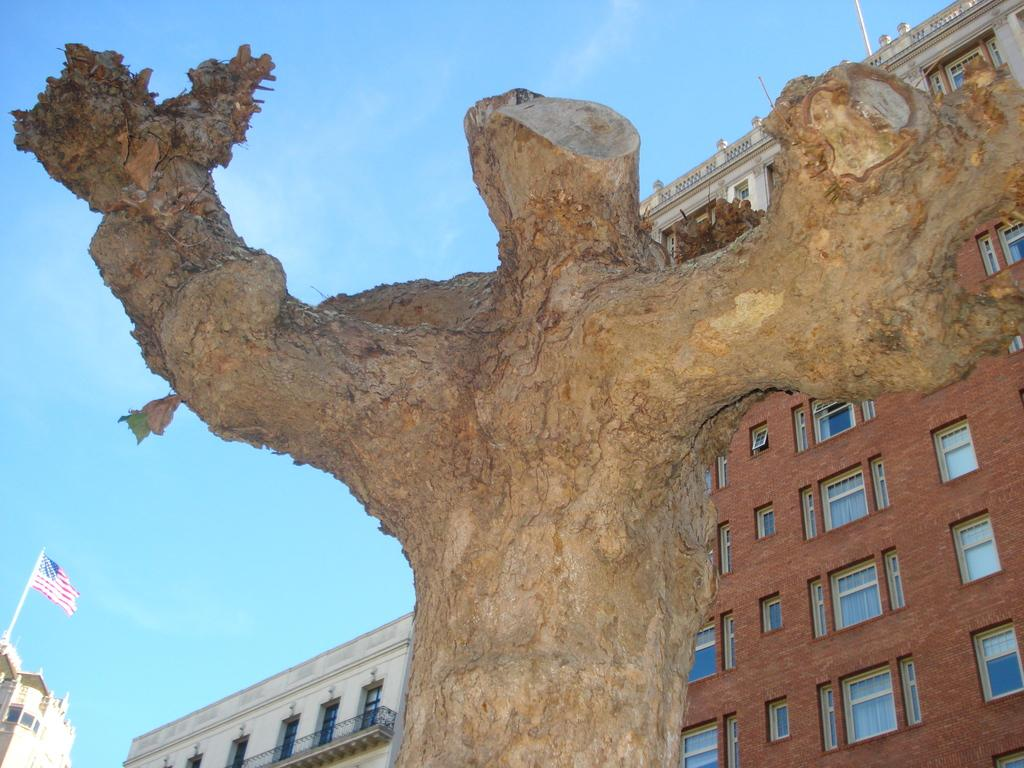What is the main subject in the center of the image? There is a tree trunk in the center of the image. What can be seen in the background of the image? There are two buildings in the background of the image. What other object is present in the image? There is a flag in the image. What is visible at the top of the image? The sky is visible at the top of the image. Can you describe the action of the robin in the image? There is no robin present in the image, so no action involving a robin can be described. What type of fruit is hanging from the tree trunk in the image? There is no fruit visible on the tree trunk in the image. 